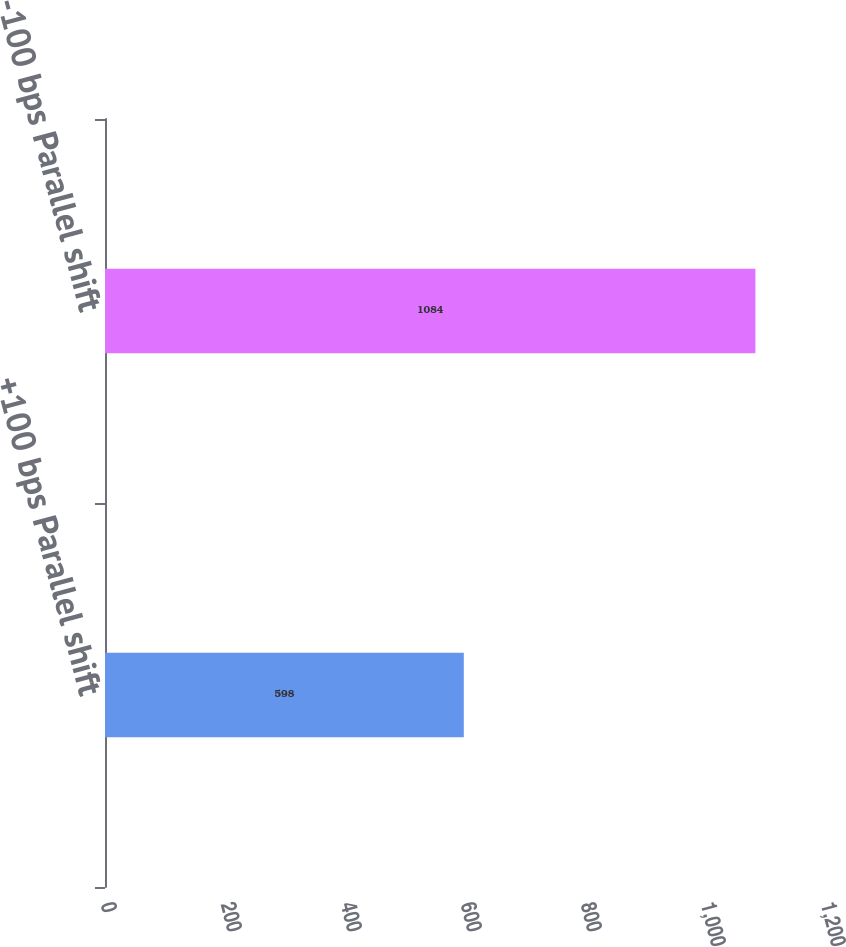Convert chart. <chart><loc_0><loc_0><loc_500><loc_500><bar_chart><fcel>+100 bps Parallel shift<fcel>-100 bps Parallel shift<nl><fcel>598<fcel>1084<nl></chart> 